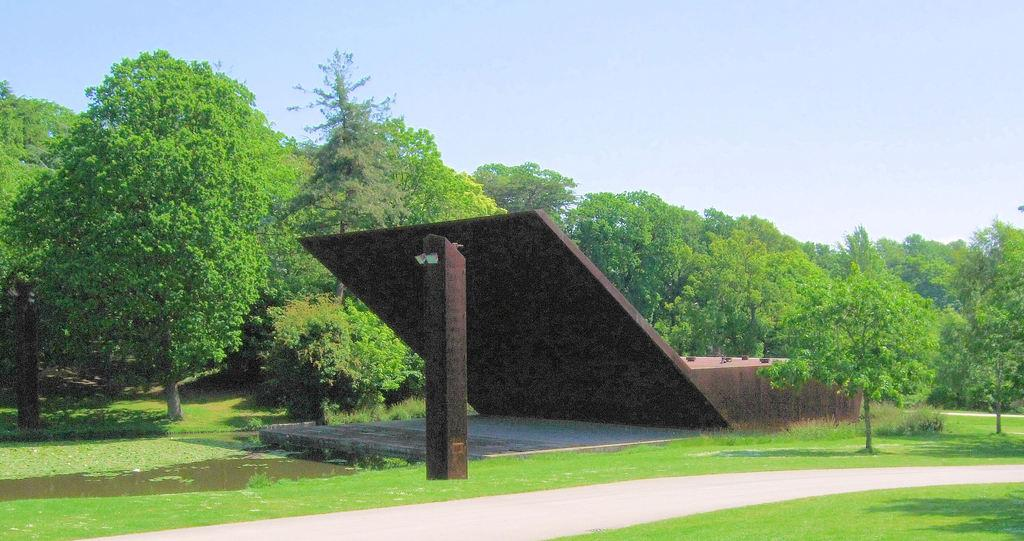What type of vegetation can be seen in the background of the image? There are trees in the background of the image. What is located at the bottom of the image? There is a road and grass at the bottom of the image. What is visible at the top of the image? The sky is present at the top of the image. Can you see a sweater hanging on the trees in the image? There is no sweater present in the image; it only features trees, a road, grass, and the sky. Is there a crate visible on the road in the image? There is no crate present in the image; it only features trees, a road, grass, and the sky. 